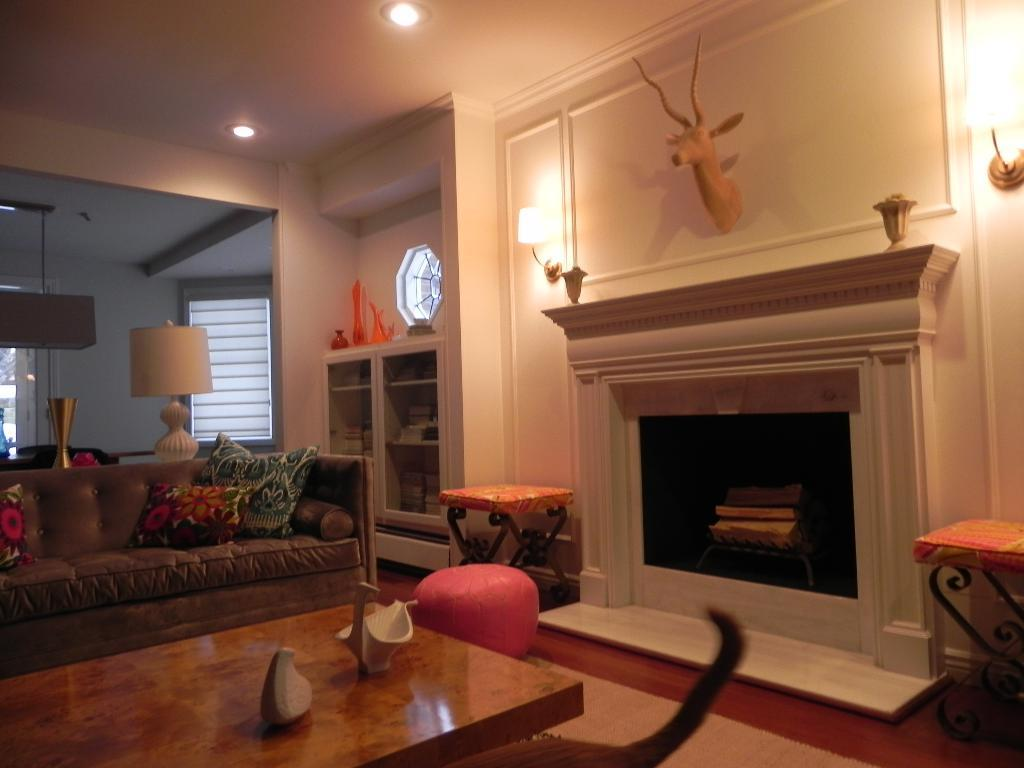What type of room is shown in the image? The image shows an inner view of a house. What type of furniture is present in the room? There is a sofa bed and chairs in the image. What is a notable feature of the room? There is a fireplace in the image. What can be used for illumination in the room? There are lights in the image. What is another piece of furniture in the room? There is a table in the image. Can you see a crook in the image? There is no crook present in the image. Is there a squirrel sitting on the table in the image? There is no squirrel present in the image. 